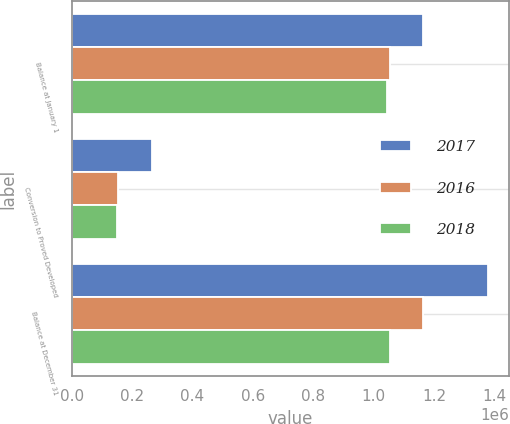Convert chart to OTSL. <chart><loc_0><loc_0><loc_500><loc_500><stacked_bar_chart><ecel><fcel>Balance at January 1<fcel>Conversion to Proved Developed<fcel>Balance at December 31<nl><fcel>2017<fcel>1.16264e+06<fcel>265718<fcel>1.37971e+06<nl><fcel>2016<fcel>1.05303e+06<fcel>152644<fcel>1.16264e+06<nl><fcel>2018<fcel>1.04564e+06<fcel>149210<fcel>1.05303e+06<nl></chart> 